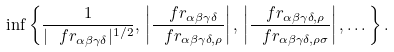<formula> <loc_0><loc_0><loc_500><loc_500>\inf \left \{ \frac { 1 } { | \ f r _ { \alpha \beta \gamma \delta } | ^ { 1 / 2 } } , \, \left | \frac { \ f r _ { \alpha \beta \gamma \delta } } { \ f r _ { \alpha \beta \gamma \delta , \rho } } \right | , \, \left | \frac { \ f r _ { \alpha \beta \gamma \delta , \rho } } { \ f r _ { \alpha \beta \gamma \delta , \rho \sigma } } \right | , \dots \right \} .</formula> 